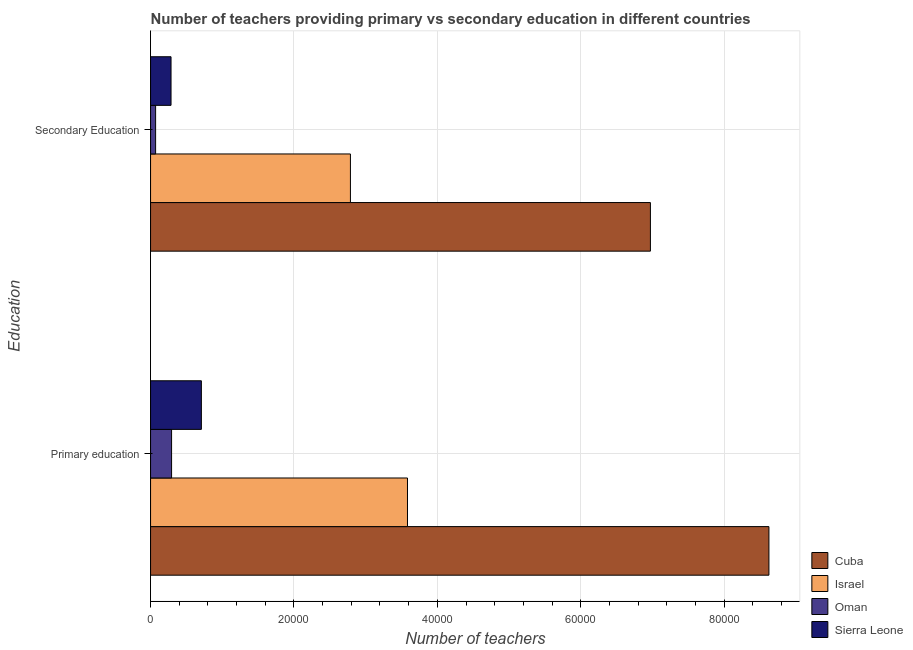How many different coloured bars are there?
Provide a short and direct response. 4. How many groups of bars are there?
Give a very brief answer. 2. Are the number of bars per tick equal to the number of legend labels?
Make the answer very short. Yes. Are the number of bars on each tick of the Y-axis equal?
Provide a short and direct response. Yes. How many bars are there on the 2nd tick from the top?
Your answer should be compact. 4. How many bars are there on the 2nd tick from the bottom?
Your answer should be compact. 4. What is the label of the 1st group of bars from the top?
Give a very brief answer. Secondary Education. What is the number of secondary teachers in Cuba?
Your response must be concise. 6.97e+04. Across all countries, what is the maximum number of primary teachers?
Your answer should be very brief. 8.63e+04. Across all countries, what is the minimum number of secondary teachers?
Offer a terse response. 704. In which country was the number of primary teachers maximum?
Your response must be concise. Cuba. In which country was the number of primary teachers minimum?
Your response must be concise. Oman. What is the total number of secondary teachers in the graph?
Provide a succinct answer. 1.01e+05. What is the difference between the number of primary teachers in Cuba and that in Sierra Leone?
Offer a terse response. 7.92e+04. What is the difference between the number of primary teachers in Oman and the number of secondary teachers in Israel?
Provide a succinct answer. -2.49e+04. What is the average number of primary teachers per country?
Give a very brief answer. 3.30e+04. What is the difference between the number of primary teachers and number of secondary teachers in Sierra Leone?
Keep it short and to the point. 4233. In how many countries, is the number of primary teachers greater than 72000 ?
Ensure brevity in your answer.  1. What is the ratio of the number of secondary teachers in Oman to that in Israel?
Make the answer very short. 0.03. In how many countries, is the number of secondary teachers greater than the average number of secondary teachers taken over all countries?
Keep it short and to the point. 2. What does the 1st bar from the top in Primary education represents?
Provide a succinct answer. Sierra Leone. What does the 1st bar from the bottom in Primary education represents?
Your answer should be very brief. Cuba. What is the difference between two consecutive major ticks on the X-axis?
Give a very brief answer. 2.00e+04. Are the values on the major ticks of X-axis written in scientific E-notation?
Offer a very short reply. No. Does the graph contain any zero values?
Give a very brief answer. No. How are the legend labels stacked?
Provide a succinct answer. Vertical. What is the title of the graph?
Offer a very short reply. Number of teachers providing primary vs secondary education in different countries. What is the label or title of the X-axis?
Make the answer very short. Number of teachers. What is the label or title of the Y-axis?
Your answer should be very brief. Education. What is the Number of teachers in Cuba in Primary education?
Your response must be concise. 8.63e+04. What is the Number of teachers of Israel in Primary education?
Ensure brevity in your answer.  3.58e+04. What is the Number of teachers in Oman in Primary education?
Give a very brief answer. 2932. What is the Number of teachers in Sierra Leone in Primary education?
Make the answer very short. 7088. What is the Number of teachers in Cuba in Secondary Education?
Provide a succinct answer. 6.97e+04. What is the Number of teachers of Israel in Secondary Education?
Your response must be concise. 2.79e+04. What is the Number of teachers of Oman in Secondary Education?
Keep it short and to the point. 704. What is the Number of teachers of Sierra Leone in Secondary Education?
Make the answer very short. 2855. Across all Education, what is the maximum Number of teachers in Cuba?
Make the answer very short. 8.63e+04. Across all Education, what is the maximum Number of teachers of Israel?
Give a very brief answer. 3.58e+04. Across all Education, what is the maximum Number of teachers in Oman?
Provide a succinct answer. 2932. Across all Education, what is the maximum Number of teachers in Sierra Leone?
Provide a succinct answer. 7088. Across all Education, what is the minimum Number of teachers in Cuba?
Your response must be concise. 6.97e+04. Across all Education, what is the minimum Number of teachers of Israel?
Your answer should be compact. 2.79e+04. Across all Education, what is the minimum Number of teachers of Oman?
Keep it short and to the point. 704. Across all Education, what is the minimum Number of teachers of Sierra Leone?
Keep it short and to the point. 2855. What is the total Number of teachers of Cuba in the graph?
Your answer should be very brief. 1.56e+05. What is the total Number of teachers in Israel in the graph?
Your response must be concise. 6.37e+04. What is the total Number of teachers in Oman in the graph?
Your response must be concise. 3636. What is the total Number of teachers in Sierra Leone in the graph?
Give a very brief answer. 9943. What is the difference between the Number of teachers in Cuba in Primary education and that in Secondary Education?
Offer a very short reply. 1.65e+04. What is the difference between the Number of teachers in Israel in Primary education and that in Secondary Education?
Provide a succinct answer. 7961. What is the difference between the Number of teachers in Oman in Primary education and that in Secondary Education?
Your answer should be very brief. 2228. What is the difference between the Number of teachers in Sierra Leone in Primary education and that in Secondary Education?
Offer a very short reply. 4233. What is the difference between the Number of teachers of Cuba in Primary education and the Number of teachers of Israel in Secondary Education?
Provide a short and direct response. 5.84e+04. What is the difference between the Number of teachers in Cuba in Primary education and the Number of teachers in Oman in Secondary Education?
Give a very brief answer. 8.55e+04. What is the difference between the Number of teachers in Cuba in Primary education and the Number of teachers in Sierra Leone in Secondary Education?
Provide a succinct answer. 8.34e+04. What is the difference between the Number of teachers of Israel in Primary education and the Number of teachers of Oman in Secondary Education?
Your response must be concise. 3.51e+04. What is the difference between the Number of teachers of Israel in Primary education and the Number of teachers of Sierra Leone in Secondary Education?
Provide a short and direct response. 3.30e+04. What is the difference between the Number of teachers of Oman in Primary education and the Number of teachers of Sierra Leone in Secondary Education?
Your answer should be compact. 77. What is the average Number of teachers in Cuba per Education?
Provide a short and direct response. 7.80e+04. What is the average Number of teachers of Israel per Education?
Offer a very short reply. 3.19e+04. What is the average Number of teachers of Oman per Education?
Your answer should be very brief. 1818. What is the average Number of teachers in Sierra Leone per Education?
Keep it short and to the point. 4971.5. What is the difference between the Number of teachers of Cuba and Number of teachers of Israel in Primary education?
Provide a short and direct response. 5.04e+04. What is the difference between the Number of teachers in Cuba and Number of teachers in Oman in Primary education?
Provide a short and direct response. 8.33e+04. What is the difference between the Number of teachers in Cuba and Number of teachers in Sierra Leone in Primary education?
Ensure brevity in your answer.  7.92e+04. What is the difference between the Number of teachers of Israel and Number of teachers of Oman in Primary education?
Provide a succinct answer. 3.29e+04. What is the difference between the Number of teachers in Israel and Number of teachers in Sierra Leone in Primary education?
Give a very brief answer. 2.88e+04. What is the difference between the Number of teachers in Oman and Number of teachers in Sierra Leone in Primary education?
Provide a succinct answer. -4156. What is the difference between the Number of teachers of Cuba and Number of teachers of Israel in Secondary Education?
Offer a terse response. 4.18e+04. What is the difference between the Number of teachers in Cuba and Number of teachers in Oman in Secondary Education?
Offer a terse response. 6.90e+04. What is the difference between the Number of teachers of Cuba and Number of teachers of Sierra Leone in Secondary Education?
Provide a short and direct response. 6.69e+04. What is the difference between the Number of teachers of Israel and Number of teachers of Oman in Secondary Education?
Your answer should be compact. 2.72e+04. What is the difference between the Number of teachers in Israel and Number of teachers in Sierra Leone in Secondary Education?
Ensure brevity in your answer.  2.50e+04. What is the difference between the Number of teachers of Oman and Number of teachers of Sierra Leone in Secondary Education?
Your response must be concise. -2151. What is the ratio of the Number of teachers in Cuba in Primary education to that in Secondary Education?
Your response must be concise. 1.24. What is the ratio of the Number of teachers in Israel in Primary education to that in Secondary Education?
Give a very brief answer. 1.29. What is the ratio of the Number of teachers of Oman in Primary education to that in Secondary Education?
Offer a very short reply. 4.16. What is the ratio of the Number of teachers of Sierra Leone in Primary education to that in Secondary Education?
Your answer should be very brief. 2.48. What is the difference between the highest and the second highest Number of teachers in Cuba?
Ensure brevity in your answer.  1.65e+04. What is the difference between the highest and the second highest Number of teachers of Israel?
Provide a succinct answer. 7961. What is the difference between the highest and the second highest Number of teachers in Oman?
Keep it short and to the point. 2228. What is the difference between the highest and the second highest Number of teachers of Sierra Leone?
Your answer should be compact. 4233. What is the difference between the highest and the lowest Number of teachers in Cuba?
Ensure brevity in your answer.  1.65e+04. What is the difference between the highest and the lowest Number of teachers in Israel?
Keep it short and to the point. 7961. What is the difference between the highest and the lowest Number of teachers of Oman?
Your response must be concise. 2228. What is the difference between the highest and the lowest Number of teachers in Sierra Leone?
Your response must be concise. 4233. 